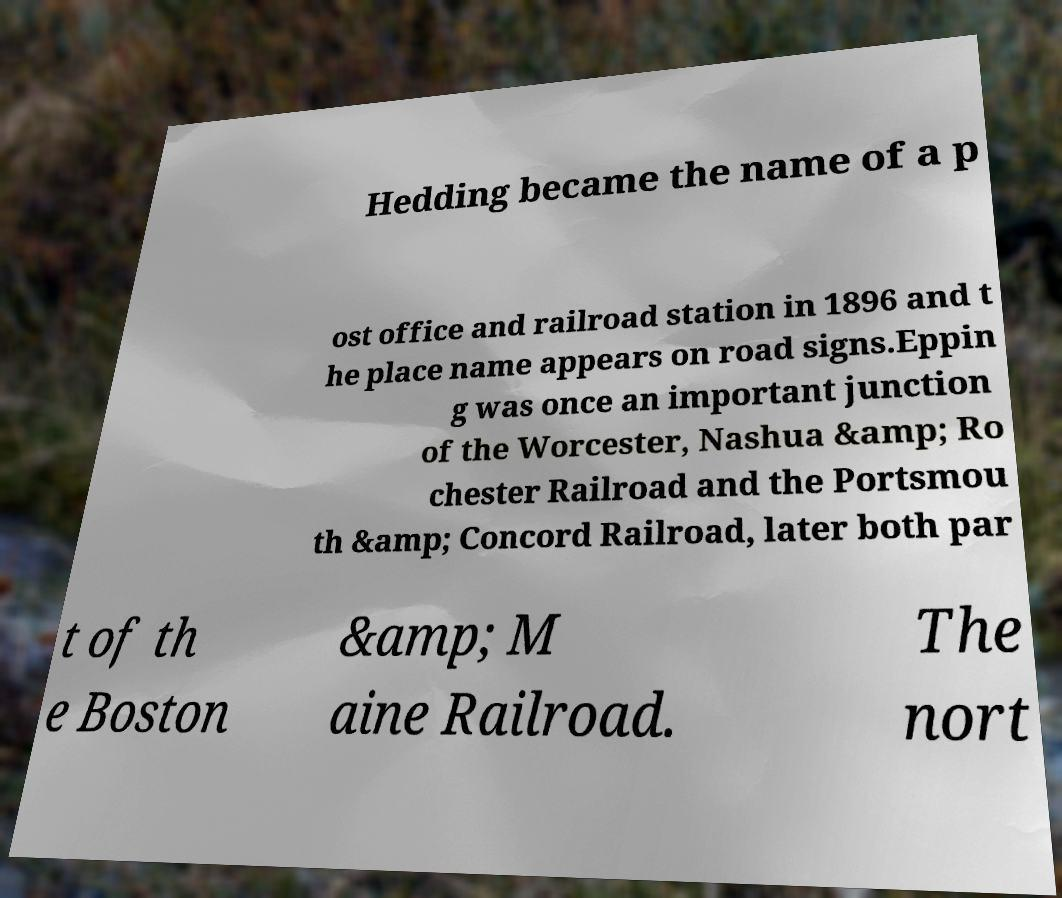Please identify and transcribe the text found in this image. Hedding became the name of a p ost office and railroad station in 1896 and t he place name appears on road signs.Eppin g was once an important junction of the Worcester, Nashua &amp; Ro chester Railroad and the Portsmou th &amp; Concord Railroad, later both par t of th e Boston &amp; M aine Railroad. The nort 